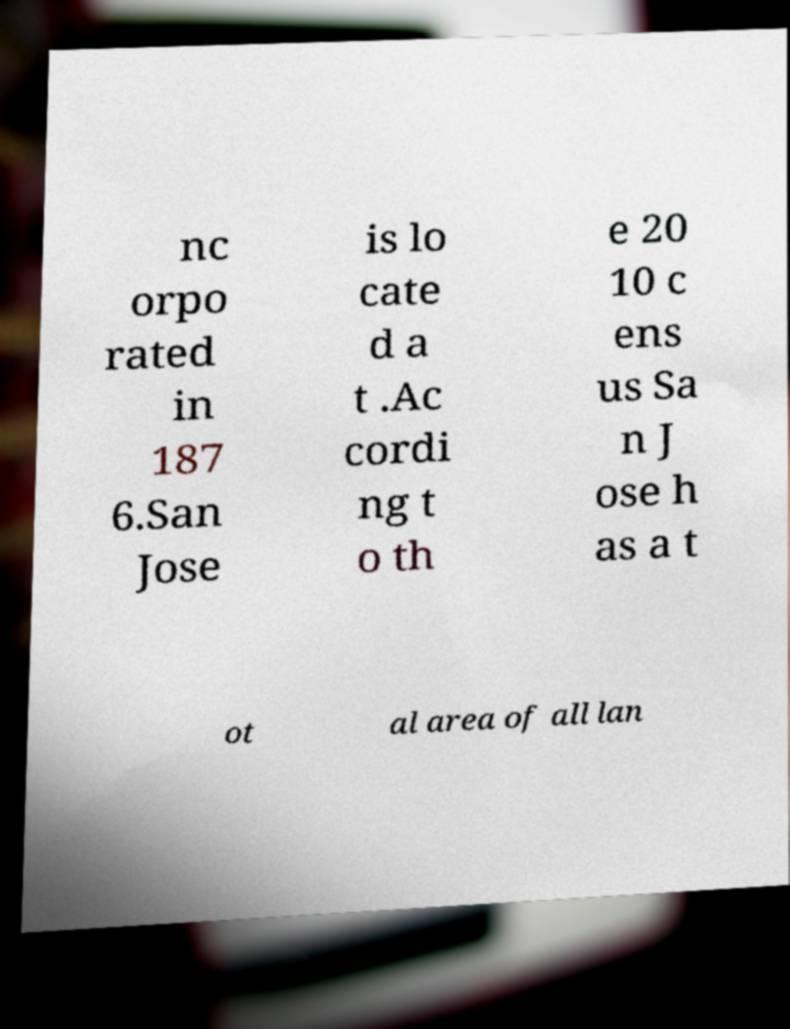Could you assist in decoding the text presented in this image and type it out clearly? nc orpo rated in 187 6.San Jose is lo cate d a t .Ac cordi ng t o th e 20 10 c ens us Sa n J ose h as a t ot al area of all lan 